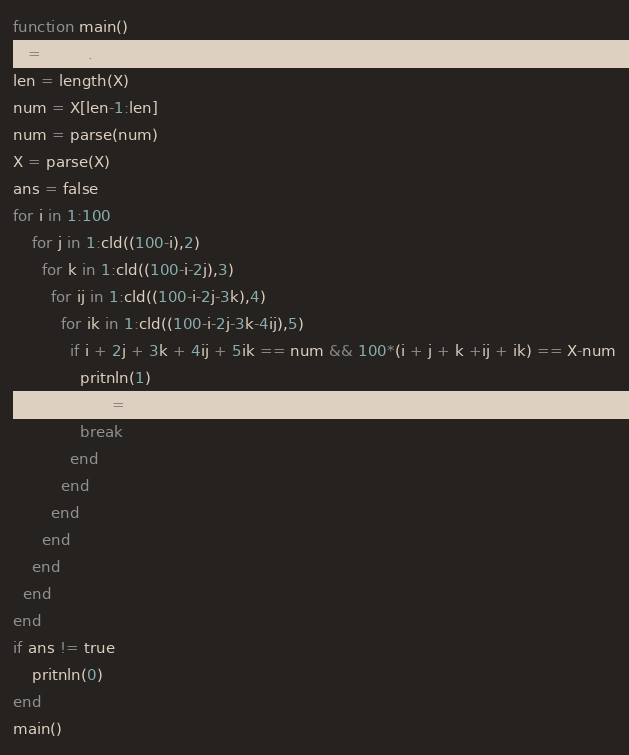<code> <loc_0><loc_0><loc_500><loc_500><_Julia_>function main()
X = parse.(split(readline()))
len = length(X)
num = X[len-1:len]
num = parse(num)
X = parse(X)  
ans = false
for i in 1:100
    for j in 1:cld((100-i),2)
      for k in 1:cld((100-i-2j),3)
        for ij in 1:cld((100-i-2j-3k),4)
          for ik in 1:cld((100-i-2j-3k-4ij),5)
            if i + 2j + 3k + 4ij + 5ik == num && 100*(i + j + k +ij + ik) == X-num
              pritnln(1)
              ans = true
              break
            end
          end
        end
      end
    end
  end
end
if ans != true
    pritnln(0)
end
main()


</code> 